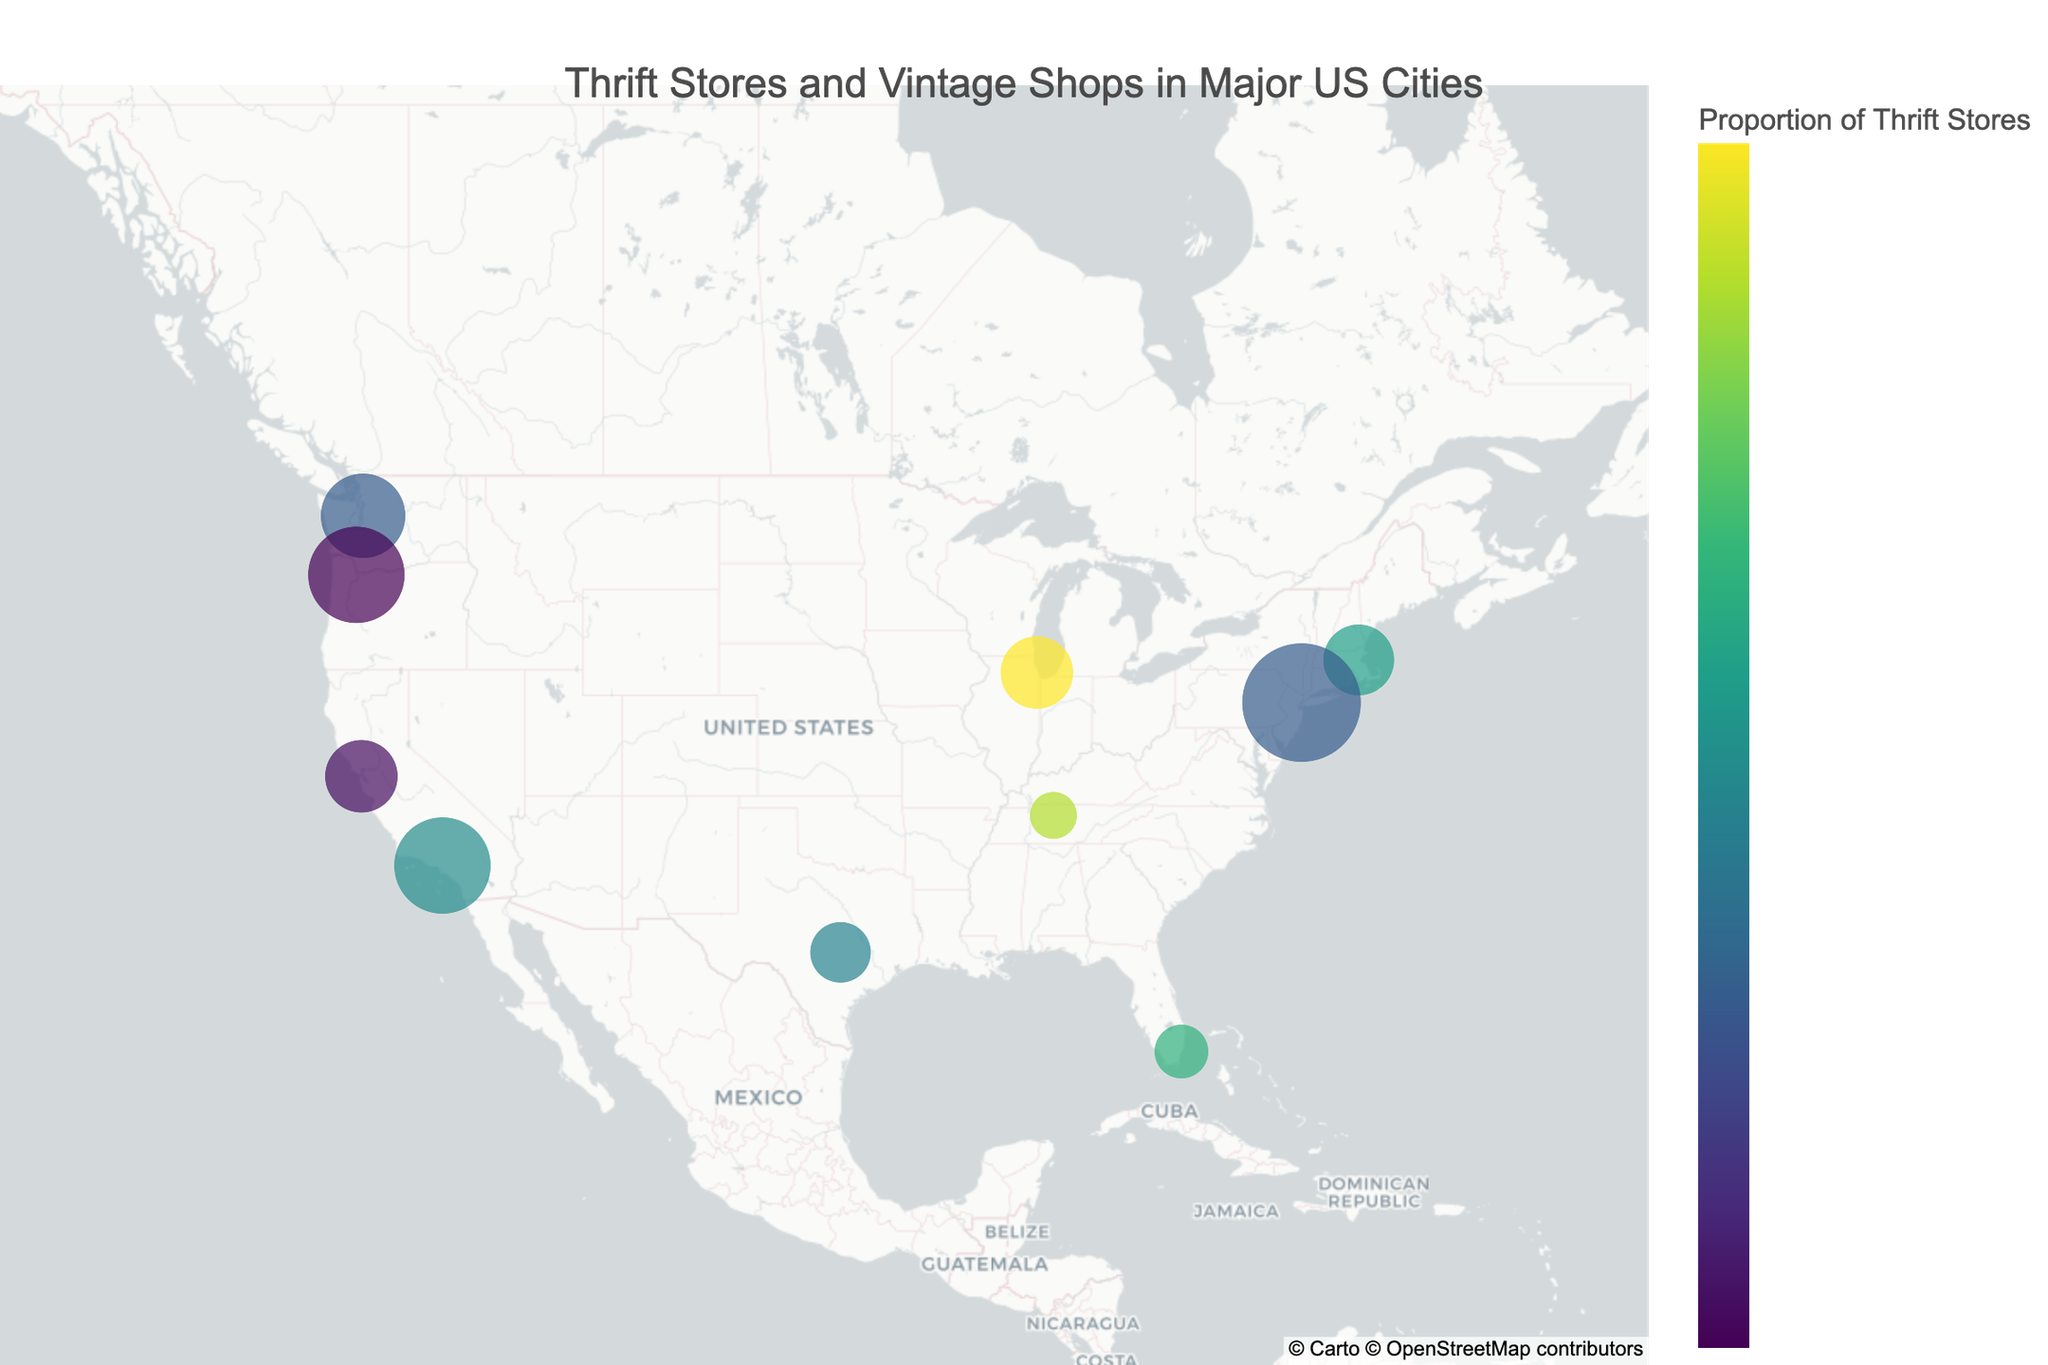What is the title of the figure? The title is usually displayed at the top center of the figure. It provides a brief description of the content. In this case, it's likely about the distribution of thrift stores and vintage shops in various cities.
Answer: Thrift Stores and Vintage Shops in Major US Cities How many cities are represented in the figure? You can count all the data points (cities) shown on the map or listed in the data. It's the total number of unique latitude and longitude coordinates.
Answer: 10 Which city has the largest number of thrift stores? Identify the city marker with the largest number of thrift stores from the data. Based on the data table, this city is indicated.
Answer: New York City Which city has the smallest number of vintage shops? Look at each city marker and compare the vintage shop counts. The city with the smallest count will be your answer.
Answer: Nashville What is the overall proportion of thrift stores to the total number of stores for New York City? Divide the number of thrift stores by the total number of both types of stores in New York City. \( \frac{42}{42 + 28} \) * 100% = 60%
Answer: 60% Which city has the highest total number of thrift and vintage shops combined? Add the thrift stores and vintage shops for each city, then identify the city with the highest sum. Based on the data: New York City (42+28=70).
Answer: New York City How does the number of thrift stores in Los Angeles compare to those in Seattle? Compare the numbers directly from the data: Los Angeles has 35 thrift stores, while Seattle has 30.
Answer: Los Angeles has 5 more thrift stores than Seattle What color indicates a higher proportion of thrift stores on the color scale? The figure uses a color scale (e.g., Viridis) where a legend or color bar shows the corresponding colors. The highest value color represents 100% thrift stores.
Answer: (The specific color here depends on the Viridis color scale; usually, the higher values are in a yellowish hue.) What is the range of the latitude coordinates in the figure for the cities represented? Find the minimum and maximum latitude values among the cities to get the range. Minimum latitude (Miami) and maximum latitude (Seattle).
Answer: 25.7617 to 47.6062 What is the reasoning behind using the size of the markers on the map? The size of markers is often employed to represent the quantity of a particular variable. Larger markers typically denote a higher value, indicating which cities have a greater combined total of thrift and vintage shops.
Answer: Larger markers represent a higher total number of thrift and vintage shops 